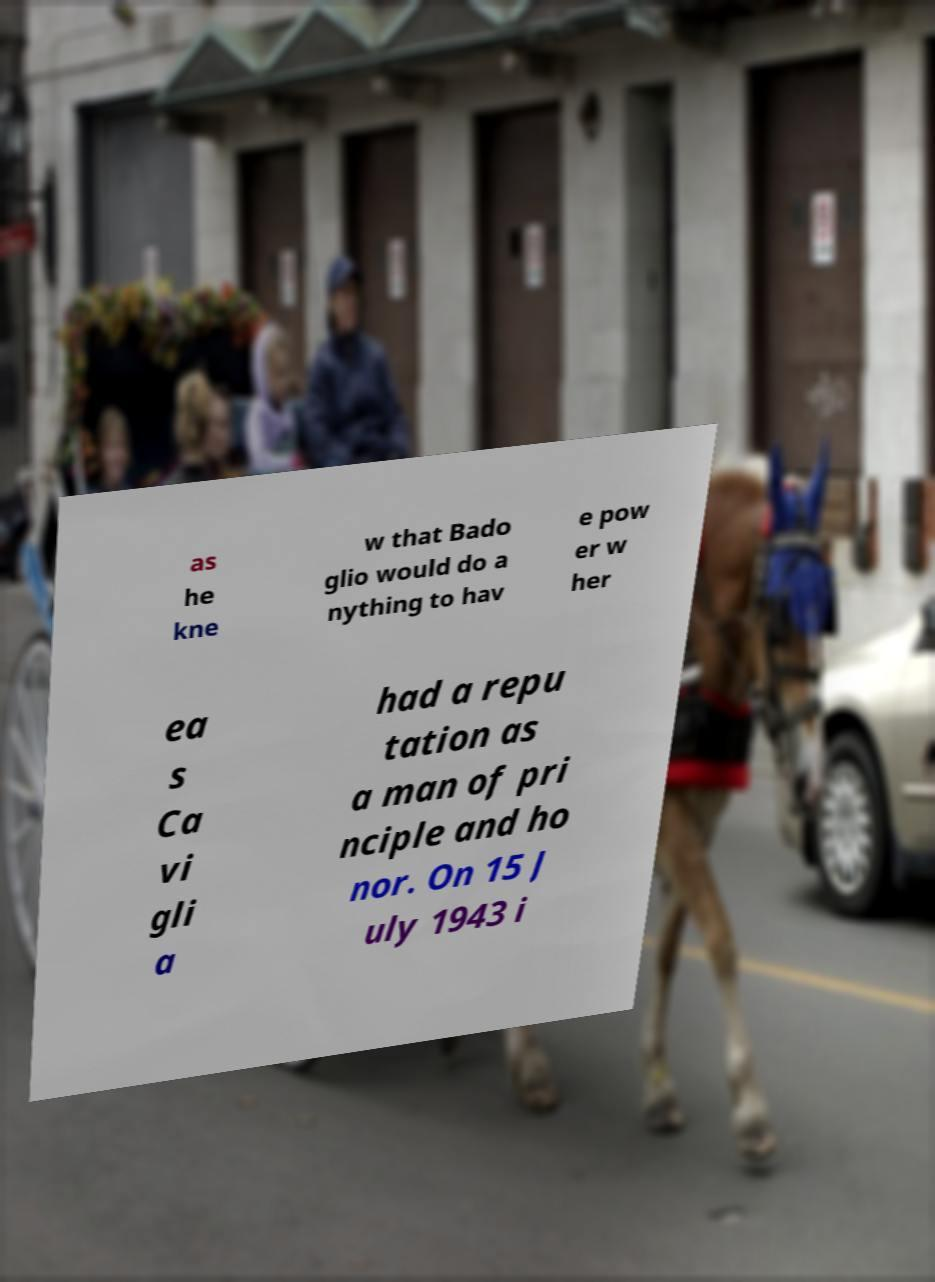Please read and relay the text visible in this image. What does it say? as he kne w that Bado glio would do a nything to hav e pow er w her ea s Ca vi gli a had a repu tation as a man of pri nciple and ho nor. On 15 J uly 1943 i 